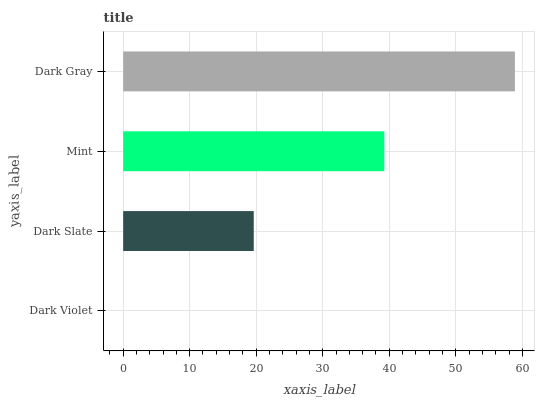Is Dark Violet the minimum?
Answer yes or no. Yes. Is Dark Gray the maximum?
Answer yes or no. Yes. Is Dark Slate the minimum?
Answer yes or no. No. Is Dark Slate the maximum?
Answer yes or no. No. Is Dark Slate greater than Dark Violet?
Answer yes or no. Yes. Is Dark Violet less than Dark Slate?
Answer yes or no. Yes. Is Dark Violet greater than Dark Slate?
Answer yes or no. No. Is Dark Slate less than Dark Violet?
Answer yes or no. No. Is Mint the high median?
Answer yes or no. Yes. Is Dark Slate the low median?
Answer yes or no. Yes. Is Dark Violet the high median?
Answer yes or no. No. Is Dark Gray the low median?
Answer yes or no. No. 